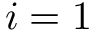Convert formula to latex. <formula><loc_0><loc_0><loc_500><loc_500>i = 1</formula> 